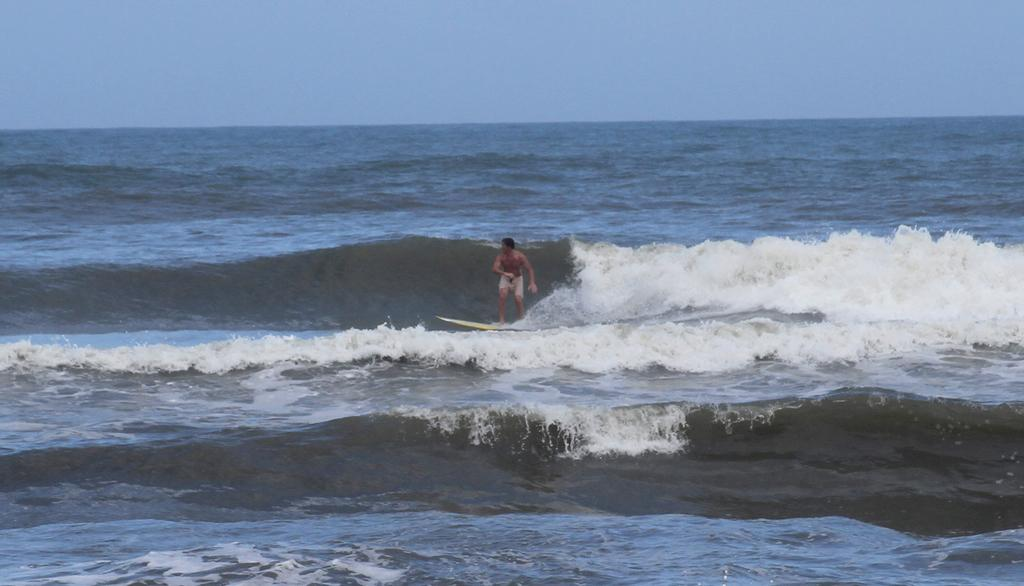What is at the bottom of the image? There is water at the bottom of the image. What activity is the man in the image engaged in? The man is surfing in the water. What can be seen in the background of the image? The sky is visible in the background of the image. Where is the bag made of copper located in the image? There is no bag made of copper present in the image. What type of park can be seen in the background of the image? There is no park visible in the background of the image; only the sky is present. 